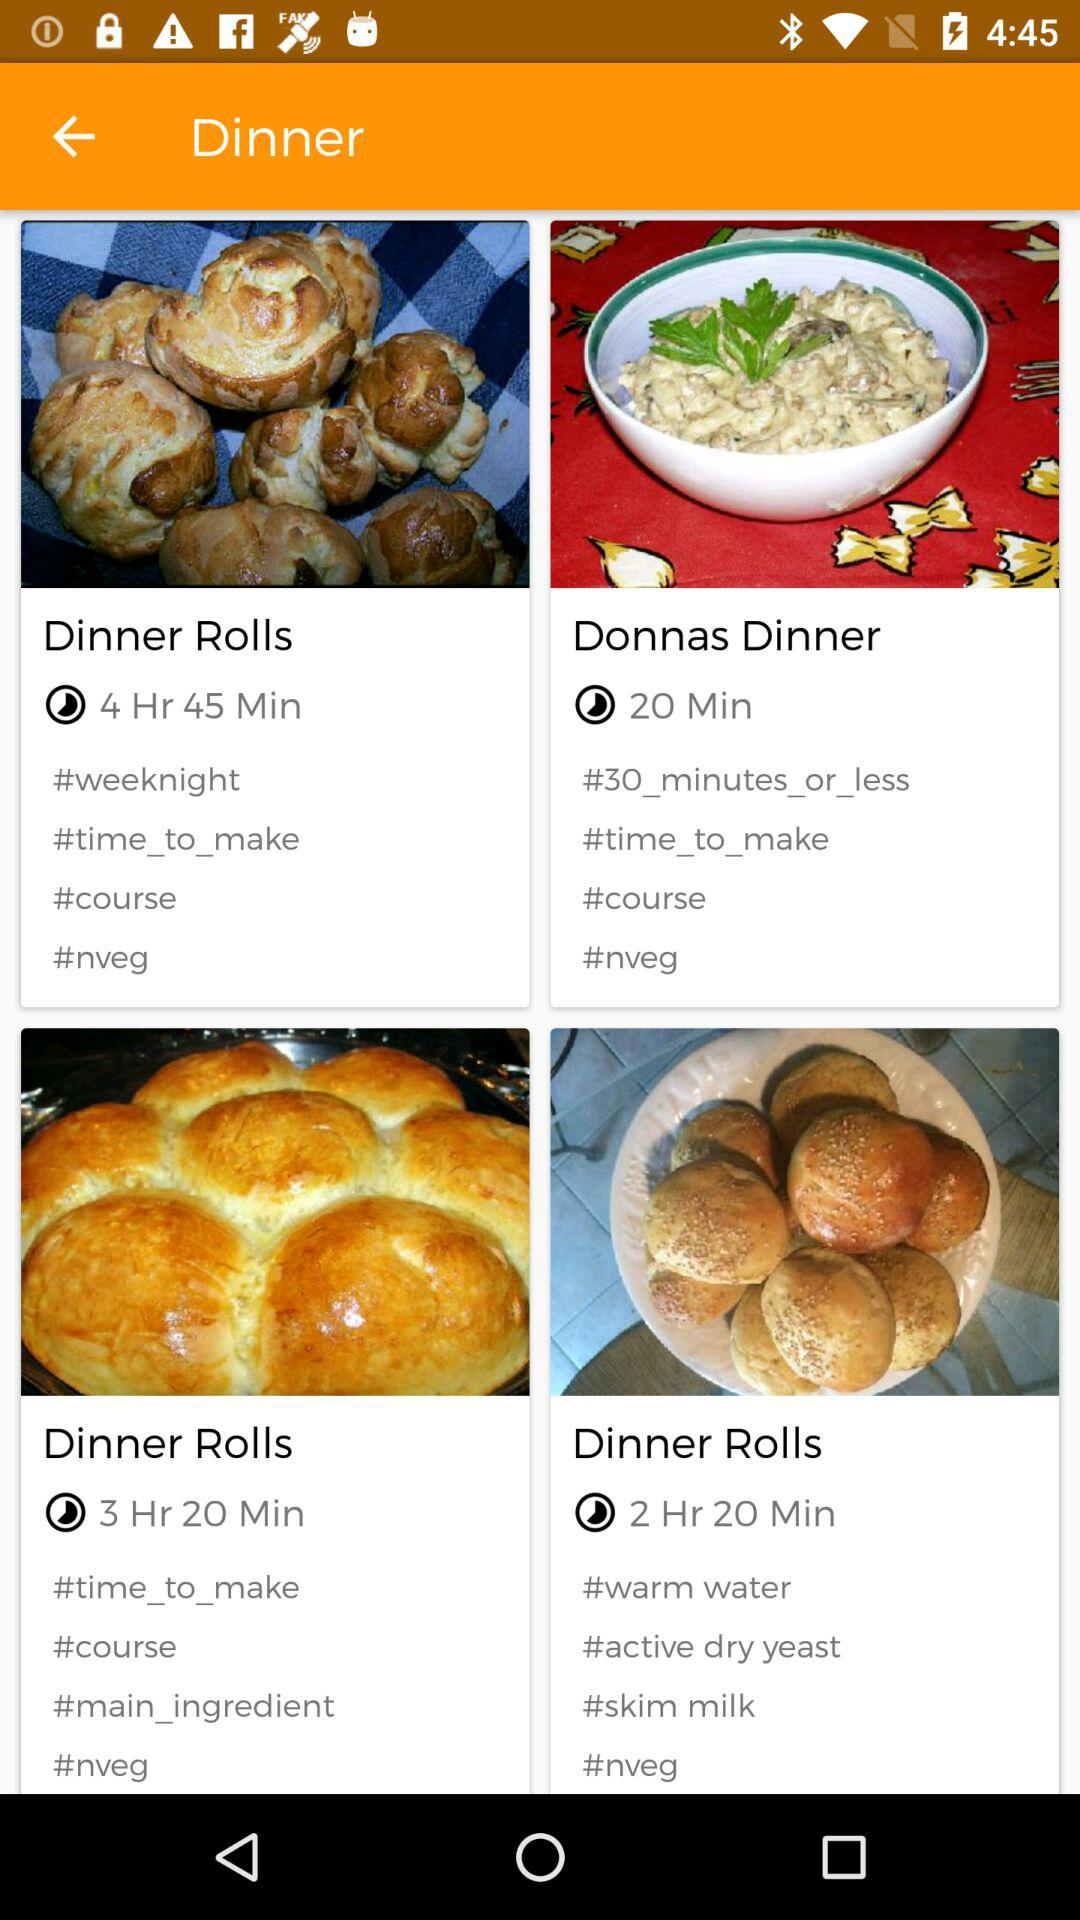Is "Donnas Dinner" vegetarian or non-vegetarian? "Donnas dinner" is non-vegetarian. 